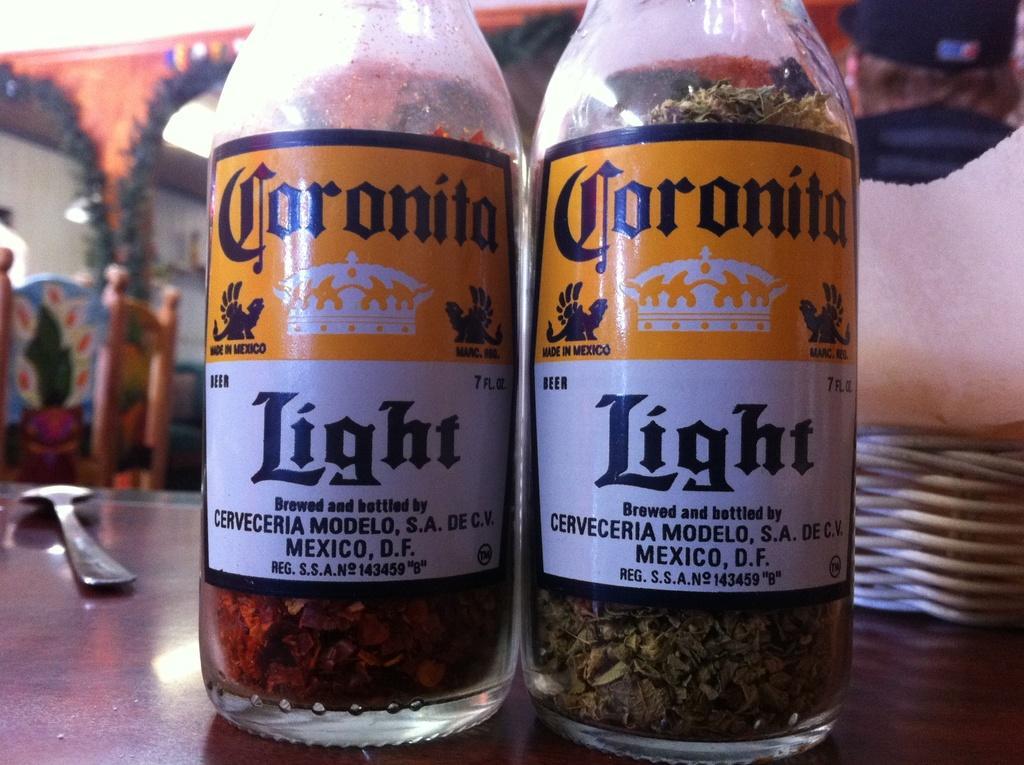How would you summarize this image in a sentence or two? In a picture on a table there are two bottles, at right corner of a picture there is one spoon and there are chairs. 